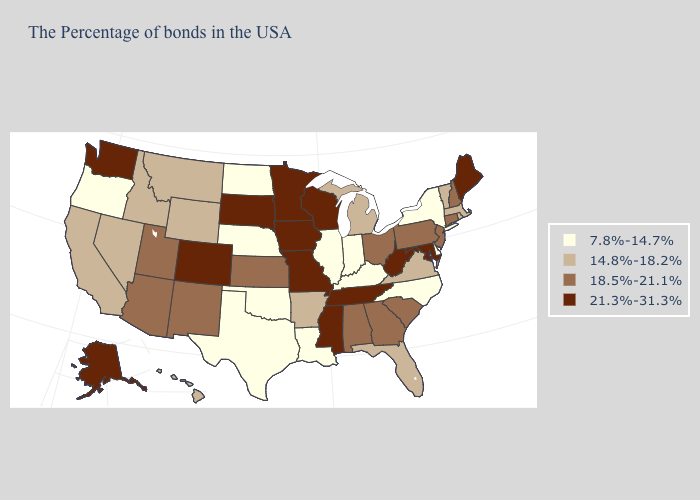Does the map have missing data?
Short answer required. No. What is the lowest value in the USA?
Answer briefly. 7.8%-14.7%. What is the value of Hawaii?
Write a very short answer. 14.8%-18.2%. What is the value of Arkansas?
Quick response, please. 14.8%-18.2%. Does North Dakota have the lowest value in the USA?
Give a very brief answer. Yes. Which states hav the highest value in the West?
Quick response, please. Colorado, Washington, Alaska. Name the states that have a value in the range 21.3%-31.3%?
Answer briefly. Maine, Maryland, West Virginia, Tennessee, Wisconsin, Mississippi, Missouri, Minnesota, Iowa, South Dakota, Colorado, Washington, Alaska. What is the value of Texas?
Write a very short answer. 7.8%-14.7%. Name the states that have a value in the range 7.8%-14.7%?
Concise answer only. New York, Delaware, North Carolina, Kentucky, Indiana, Illinois, Louisiana, Nebraska, Oklahoma, Texas, North Dakota, Oregon. What is the value of Ohio?
Quick response, please. 18.5%-21.1%. What is the value of Alaska?
Short answer required. 21.3%-31.3%. What is the lowest value in the USA?
Concise answer only. 7.8%-14.7%. Is the legend a continuous bar?
Answer briefly. No. What is the value of Virginia?
Short answer required. 14.8%-18.2%. What is the highest value in the West ?
Keep it brief. 21.3%-31.3%. 